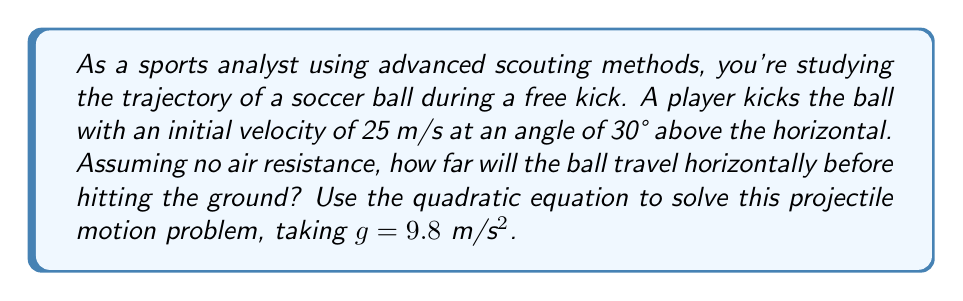Give your solution to this math problem. To solve this problem, we'll use the quadratic equation derived from the equations of motion for projectile motion. Let's break it down step-by-step:

1) First, let's recall the relevant equations:
   
   Horizontal motion: $x = v_0 \cos(\theta) \cdot t$
   Vertical motion: $y = v_0 \sin(\theta) \cdot t - \frac{1}{2}gt^2$

2) We're interested in the horizontal distance when the ball hits the ground, which occurs when y = 0. So, we can set up the equation:

   $0 = v_0 \sin(\theta) \cdot t - \frac{1}{2}gt^2$

3) Rearrange this into standard quadratic form $(at^2 + bt + c = 0)$:

   $\frac{1}{2}gt^2 - v_0 \sin(\theta) \cdot t = 0$

4) Now, let's plug in our known values:
   $v_0 = 25$ m/s
   $\theta = 30°$
   $g = 9.8$ m/s²

   $\frac{1}{2}(9.8)t^2 - 25\sin(30°) \cdot t = 0$

5) Simplify:
   $4.9t^2 - 12.5t = 0$

6) Factor out t:
   $t(4.9t - 12.5) = 0$

7) Solve for t:
   $t = 0$ or $t = \frac{12.5}{4.9} \approx 2.55$ seconds

   We're interested in the non-zero solution, so $t \approx 2.55$ seconds.

8) Now that we know the time of flight, we can use the horizontal motion equation to find the distance:

   $x = v_0 \cos(\theta) \cdot t$
   $x = 25 \cos(30°) \cdot 2.55$
   $x = 25 \cdot (\frac{\sqrt{3}}{2}) \cdot 2.55$
   $x \approx 55.22$ meters

Therefore, the ball will travel approximately 55.22 meters horizontally before hitting the ground.
Answer: The ball will travel approximately 55.22 meters horizontally before hitting the ground. 